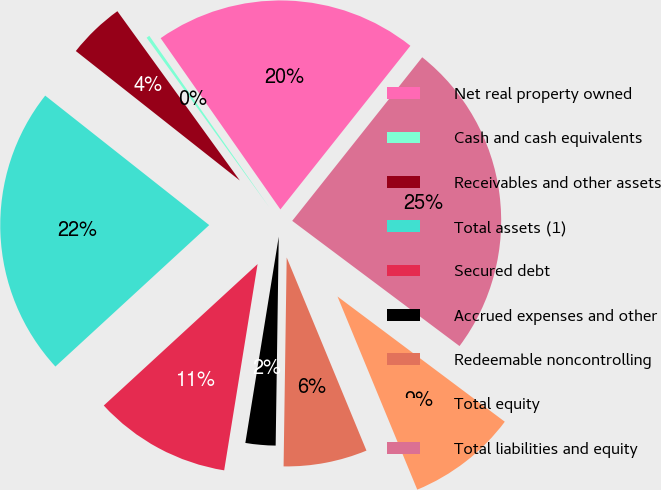Convert chart to OTSL. <chart><loc_0><loc_0><loc_500><loc_500><pie_chart><fcel>Net real property owned<fcel>Cash and cash equivalents<fcel>Receivables and other assets<fcel>Total assets (1)<fcel>Secured debt<fcel>Accrued expenses and other<fcel>Redeemable noncontrolling<fcel>Total equity<fcel>Total liabilities and equity<nl><fcel>20.4%<fcel>0.25%<fcel>4.4%<fcel>22.47%<fcel>10.61%<fcel>2.32%<fcel>6.47%<fcel>8.54%<fcel>24.54%<nl></chart> 